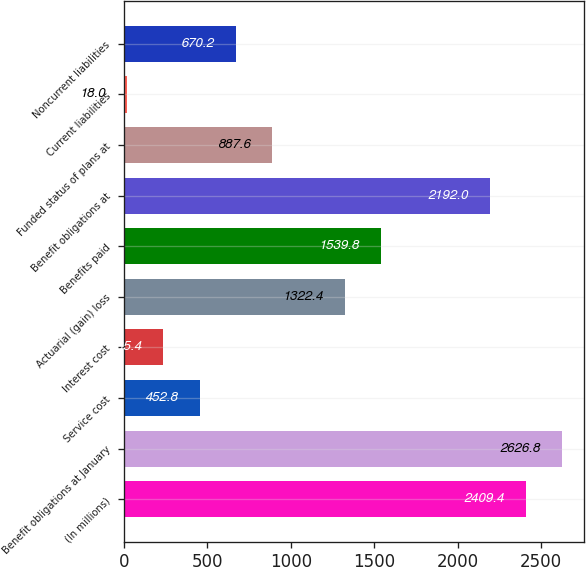Convert chart to OTSL. <chart><loc_0><loc_0><loc_500><loc_500><bar_chart><fcel>(In millions)<fcel>Benefit obligations at January<fcel>Service cost<fcel>Interest cost<fcel>Actuarial (gain) loss<fcel>Benefits paid<fcel>Benefit obligations at<fcel>Funded status of plans at<fcel>Current liabilities<fcel>Noncurrent liabilities<nl><fcel>2409.4<fcel>2626.8<fcel>452.8<fcel>235.4<fcel>1322.4<fcel>1539.8<fcel>2192<fcel>887.6<fcel>18<fcel>670.2<nl></chart> 